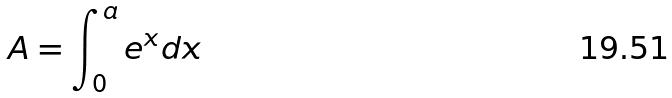Convert formula to latex. <formula><loc_0><loc_0><loc_500><loc_500>A = \int _ { 0 } ^ { a } e ^ { x } d x</formula> 